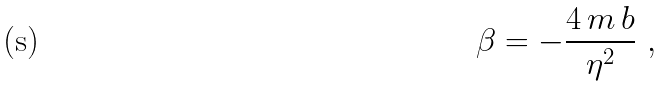Convert formula to latex. <formula><loc_0><loc_0><loc_500><loc_500>\beta = - \frac { 4 \, m \, b } { \eta ^ { 2 } } \ ,</formula> 